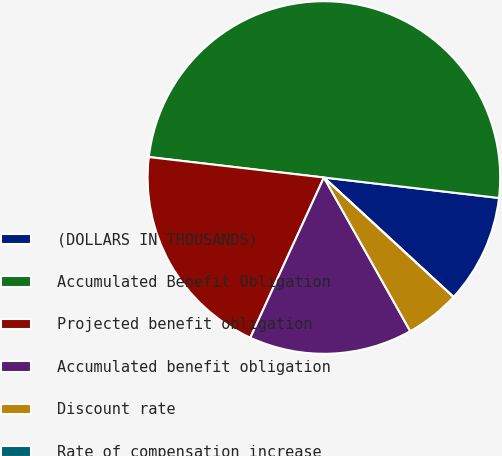Convert chart to OTSL. <chart><loc_0><loc_0><loc_500><loc_500><pie_chart><fcel>(DOLLARS IN THOUSANDS)<fcel>Accumulated Benefit Obligation<fcel>Projected benefit obligation<fcel>Accumulated benefit obligation<fcel>Discount rate<fcel>Rate of compensation increase<nl><fcel>10.0%<fcel>50.0%<fcel>20.0%<fcel>15.0%<fcel>5.0%<fcel>0.0%<nl></chart> 